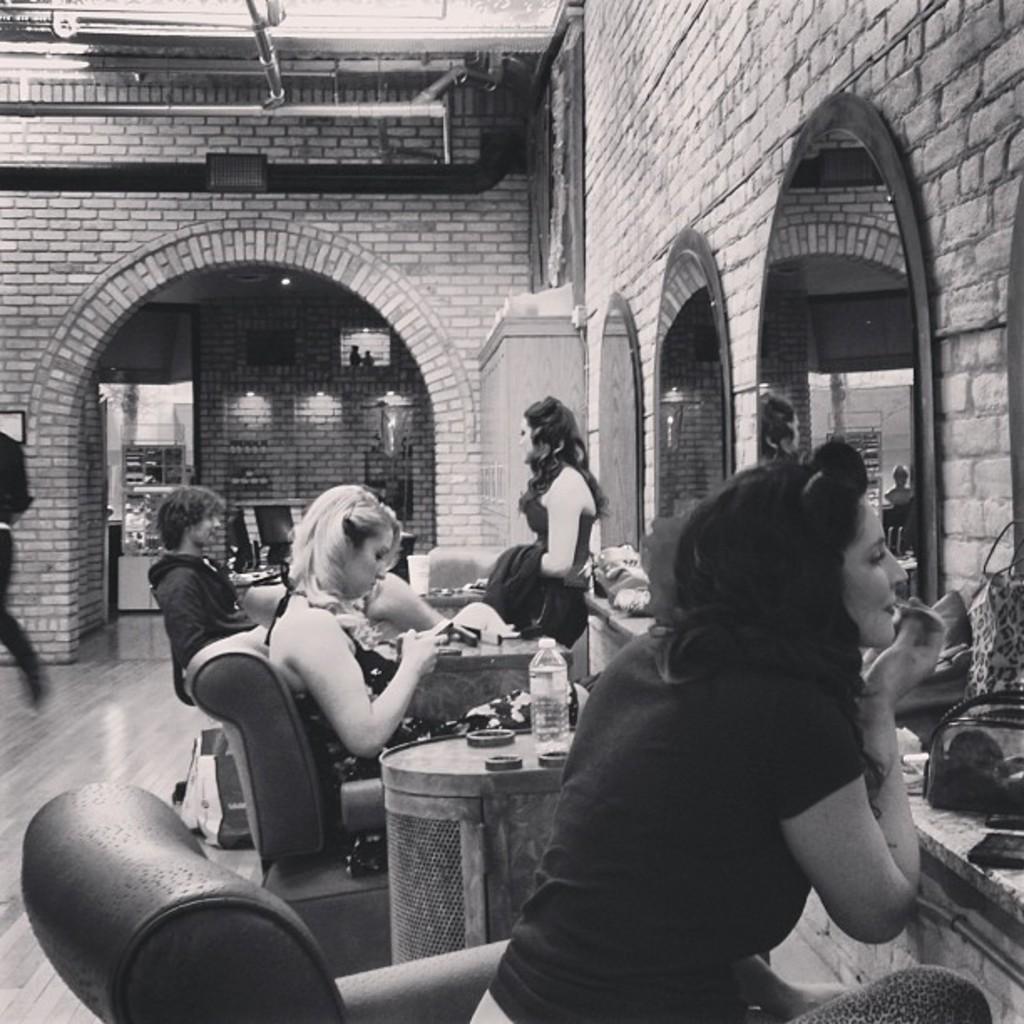Could you give a brief overview of what you see in this image? The picture is clicked in a hotel where there are people are getting ready and there are also mirrors to the right side of the image. 